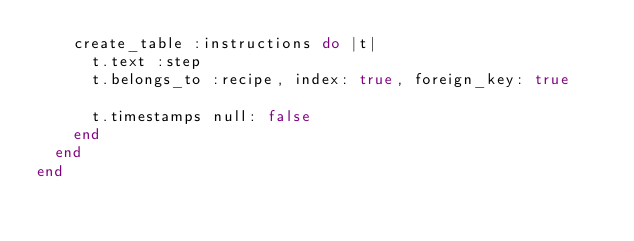<code> <loc_0><loc_0><loc_500><loc_500><_Ruby_>    create_table :instructions do |t|
      t.text :step
      t.belongs_to :recipe, index: true, foreign_key: true

      t.timestamps null: false
    end
  end
end
</code> 